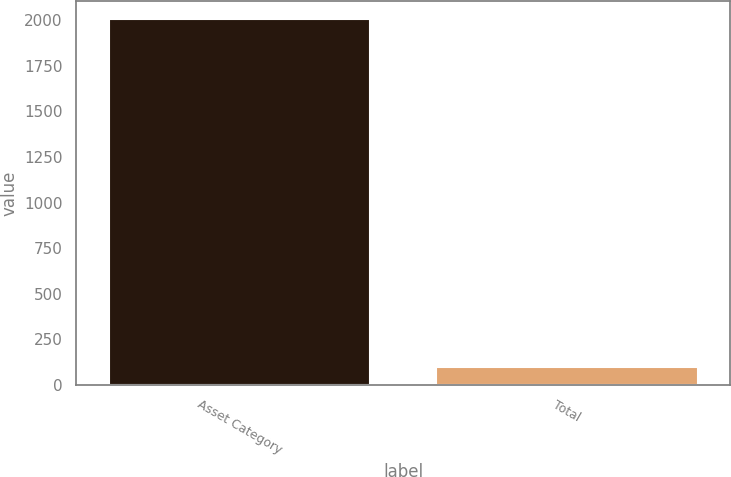<chart> <loc_0><loc_0><loc_500><loc_500><bar_chart><fcel>Asset Category<fcel>Total<nl><fcel>2006<fcel>100<nl></chart> 